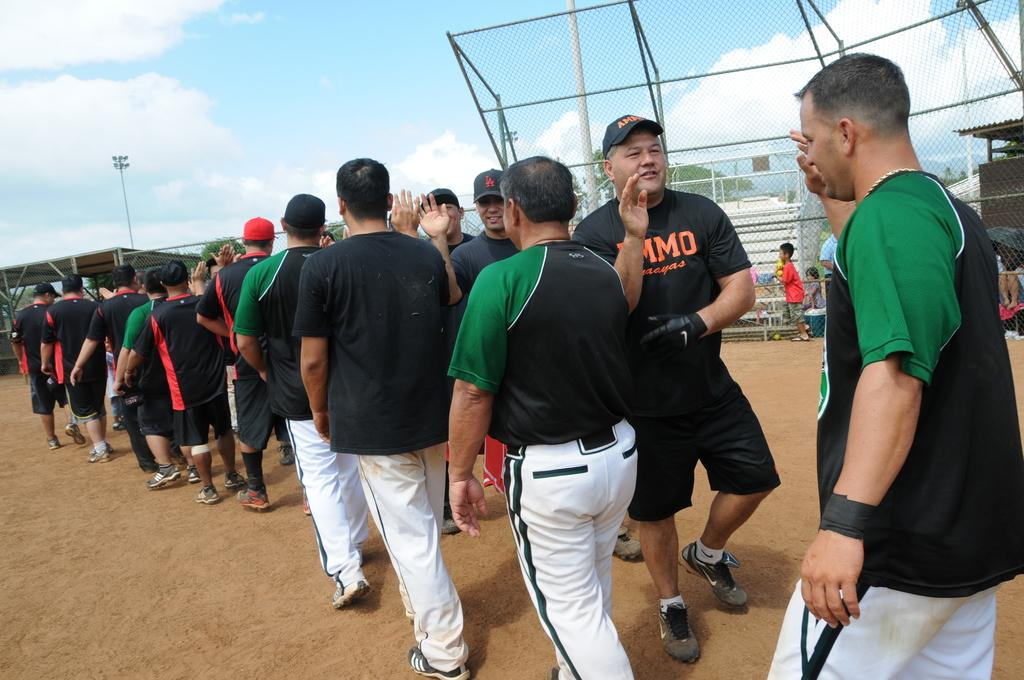Provide a one-sentence caption for the provided image. A man wears a black shirt with the letters M, M and O visible in orange. 